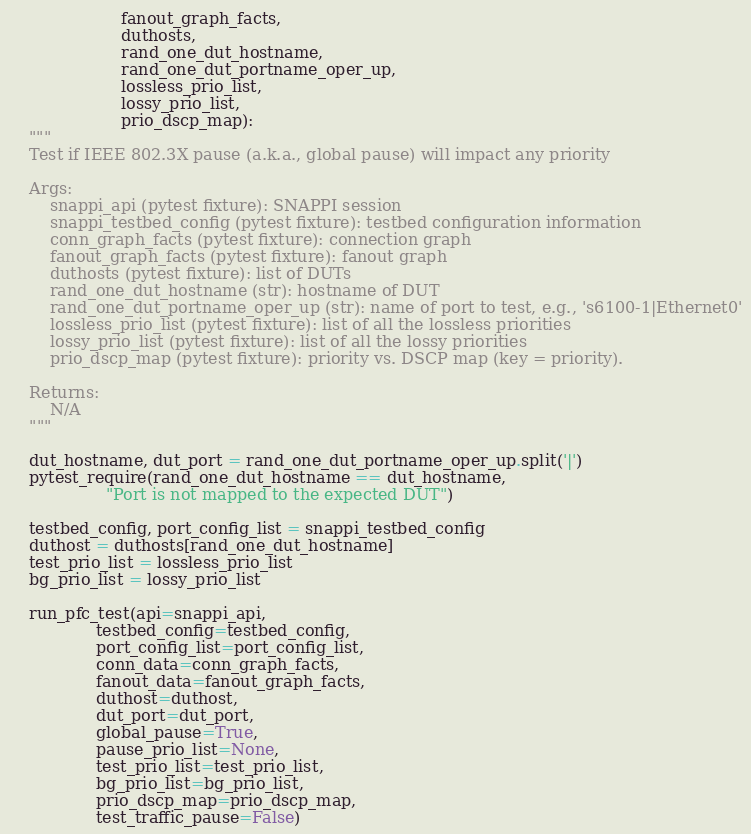<code> <loc_0><loc_0><loc_500><loc_500><_Python_>                      fanout_graph_facts,
                      duthosts,
                      rand_one_dut_hostname,
                      rand_one_dut_portname_oper_up,
                      lossless_prio_list,
                      lossy_prio_list,
                      prio_dscp_map):
    """
    Test if IEEE 802.3X pause (a.k.a., global pause) will impact any priority

    Args:
        snappi_api (pytest fixture): SNAPPI session
        snappi_testbed_config (pytest fixture): testbed configuration information
        conn_graph_facts (pytest fixture): connection graph
        fanout_graph_facts (pytest fixture): fanout graph
        duthosts (pytest fixture): list of DUTs
        rand_one_dut_hostname (str): hostname of DUT
        rand_one_dut_portname_oper_up (str): name of port to test, e.g., 's6100-1|Ethernet0'
        lossless_prio_list (pytest fixture): list of all the lossless priorities
        lossy_prio_list (pytest fixture): list of all the lossy priorities
        prio_dscp_map (pytest fixture): priority vs. DSCP map (key = priority).

    Returns:
        N/A
    """

    dut_hostname, dut_port = rand_one_dut_portname_oper_up.split('|')
    pytest_require(rand_one_dut_hostname == dut_hostname,
                   "Port is not mapped to the expected DUT")

    testbed_config, port_config_list = snappi_testbed_config
    duthost = duthosts[rand_one_dut_hostname]
    test_prio_list = lossless_prio_list
    bg_prio_list = lossy_prio_list

    run_pfc_test(api=snappi_api,
                 testbed_config=testbed_config,
                 port_config_list=port_config_list,
                 conn_data=conn_graph_facts,
                 fanout_data=fanout_graph_facts,
                 duthost=duthost,
                 dut_port=dut_port,
                 global_pause=True,
                 pause_prio_list=None,
                 test_prio_list=test_prio_list,
                 bg_prio_list=bg_prio_list,
                 prio_dscp_map=prio_dscp_map,
                 test_traffic_pause=False)
</code> 